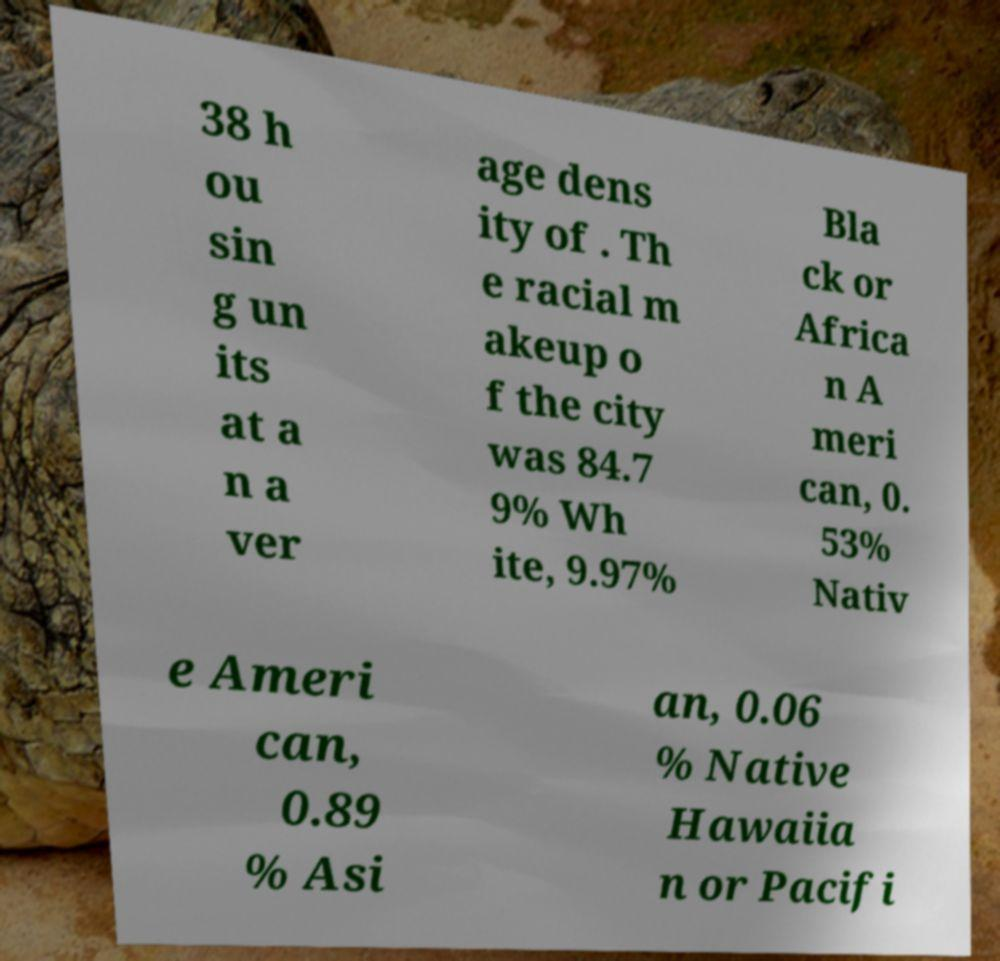Could you extract and type out the text from this image? 38 h ou sin g un its at a n a ver age dens ity of . Th e racial m akeup o f the city was 84.7 9% Wh ite, 9.97% Bla ck or Africa n A meri can, 0. 53% Nativ e Ameri can, 0.89 % Asi an, 0.06 % Native Hawaiia n or Pacifi 